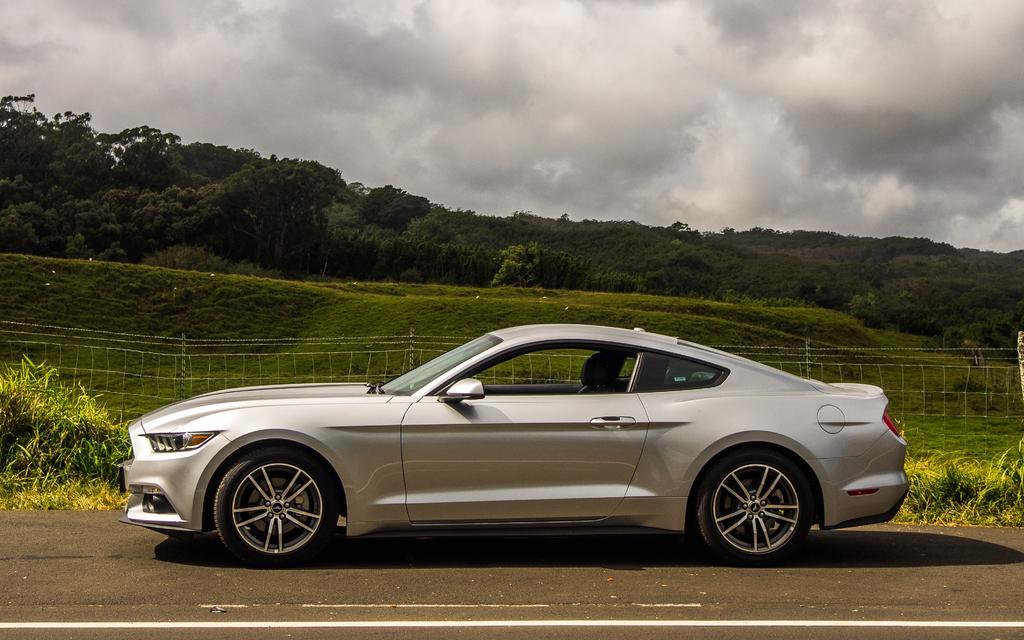How would you summarize this image in a sentence or two? There is a car on the road. Here we can see grass, fence, plants, and trees. In the background there is sky with clouds. 